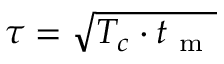Convert formula to latex. <formula><loc_0><loc_0><loc_500><loc_500>\tau = \sqrt { T _ { c } \cdot t _ { m } }</formula> 